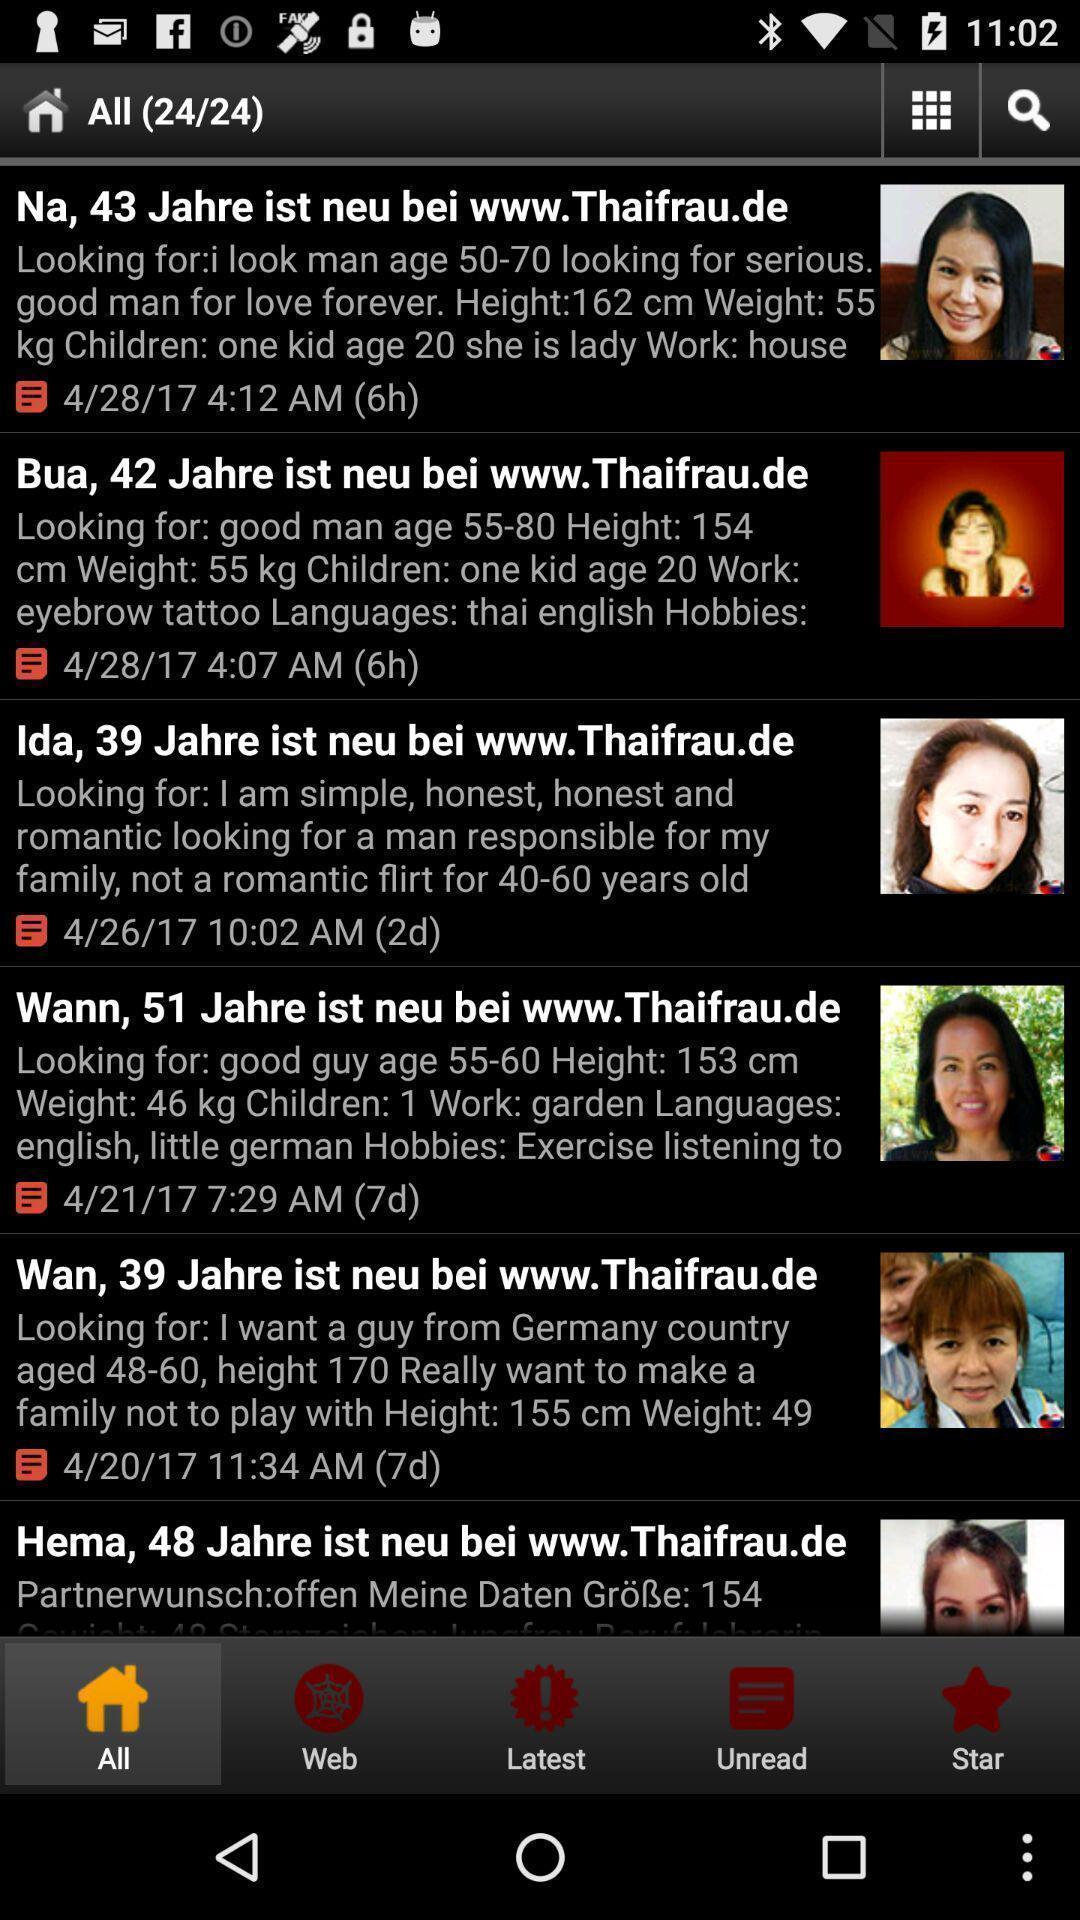Please provide a description for this image. Screen displaying home page. 